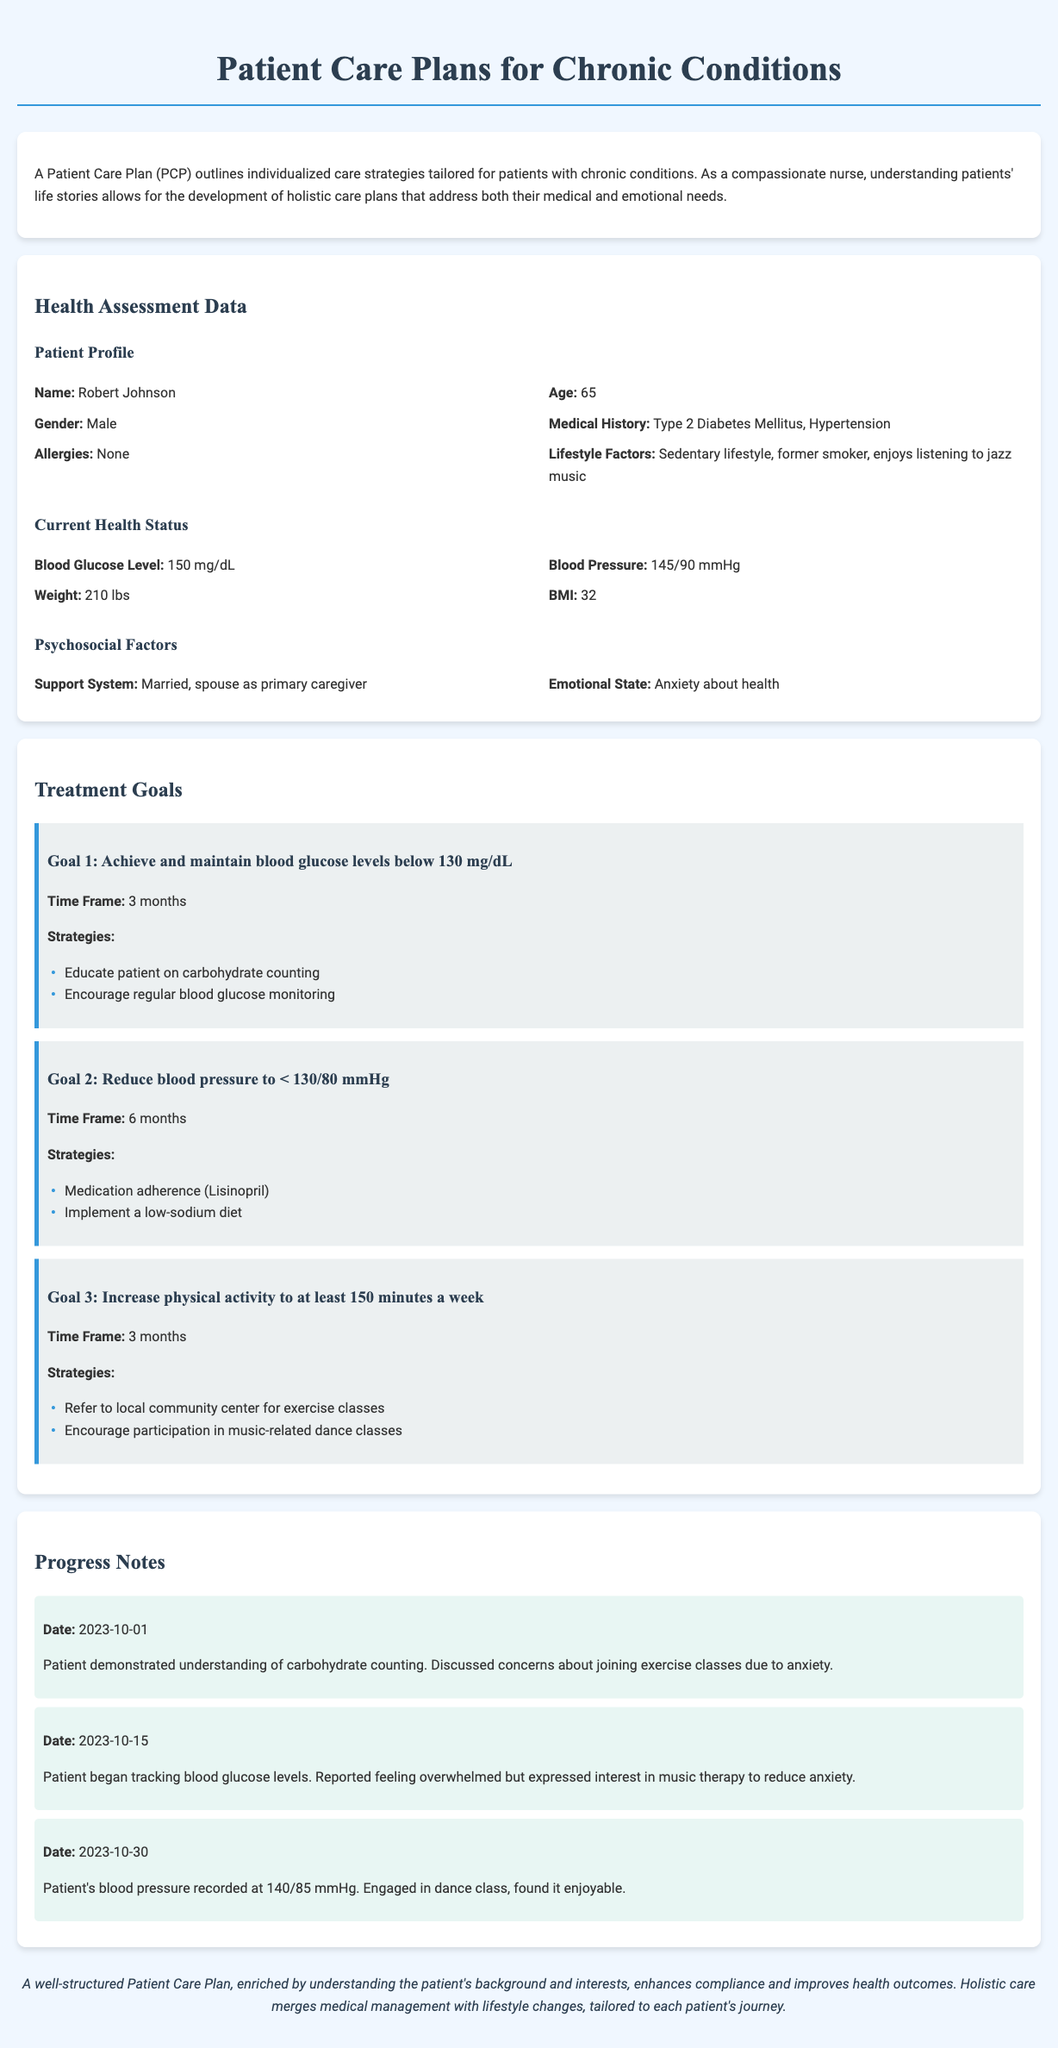What is the patient's name? The patient's name is listed in the Patient Profile section of the document.
Answer: Robert Johnson What is the blood glucose level? The blood glucose level is provided in the Current Health Status section of the document.
Answer: 150 mg/dL What is the goal for blood pressure reduction? The goal for blood pressure reduction can be found in the Treatment Goals section of the document.
Answer: < 130/80 mmHg How many minutes of physical activity is the patient encouraged to increase? The specific number of minutes for physical activity is mentioned in the Treatment Goals section.
Answer: 150 minutes What is the date of the last progress note? The last progress note date is outlined in the Progress Notes section.
Answer: 2023-10-30 What strategy is suggested for managing anxiety? The strategy for managing anxiety is mentioned in multiple sections of the document under various treatment goals.
Answer: Music therapy What chronic conditions does the patient have? The chronic conditions are outlined in the Medical History part of the Patient Profile section.
Answer: Type 2 Diabetes Mellitus, Hypertension What emotional state is noted for the patient? The emotional state of the patient is identified in the Psychosocial Factors section.
Answer: Anxiety about health What treatment goal is aimed at carbohydrate counting? The specific treatment goal addressing carbohydrate counting can be found in the Treatment Goals section.
Answer: Goal 1: Achieve and maintain blood glucose levels below 130 mg/dL 